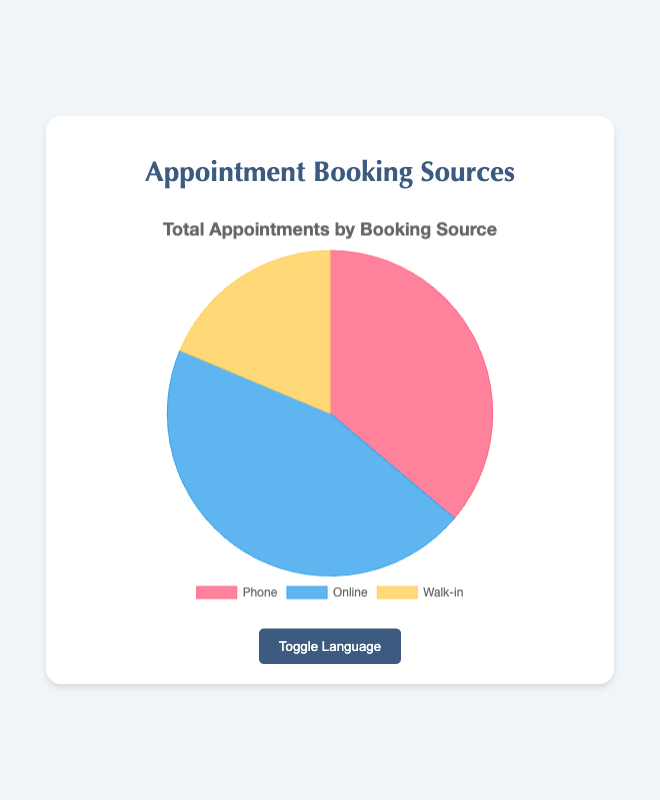What source had the highest number of total appointments? To answer this, sum the appointments from each source across all months. The totals are: Phone: 600, Online: 750, Walk-in: 310. The highest total number comes from the Online source.
Answer: Online How many more appointments were booked online than by phone? To find this, subtract the total phone appointments from total online appointments. Online: 750, Phone: 600. So, 750 - 600 = 150.
Answer: 150 What is the average number of appointments booked by walk-in each month? To determine the average, divide the total walk-in appointments by the number of months. Total walk-in: 310, Months: 5. So, 310 / 5 = 62.
Answer: 62 Which month had the highest number of phone appointments? Review the phone appointment data for each month. January: 120, February: 110, March: 100, April: 130, May: 140. May has the highest number with 140 appointments.
Answer: May If you combined phone and walk-in bookings, would they exceed online bookings? Sum the total phone and walk-in bookings and compare with the total online bookings. Phone + Walk-in: 600 + 310 = 910, Online: 750. Since 910 > 750, combined phone and walk-in exceed online bookings.
Answer: Yes In which month did online appoints surpass phone appointments by the largest margin? Calculate the difference between online and phone appointments for each month and find the one with the largest margin. January: 150 - 120 = 30, February: 160 - 110 = 50, March: 170 - 100 = 70, April: 140 - 130 = 10, May: 130 - 140 = -10. March has the largest margin of 70.
Answer: March What percentage of total appointments were booked by phone? To find this, divide the total phone appointments by the total of all appointments and multiply by 100. Total appointments: 1660, Phone: 600. So, (600 / 1660) * 100 ≈ 36.14%.
Answer: 36.14% What color represents the walk-in bookings in the chart? By observing the pie chart, identify the color segment representing walk-in, which is the smallest segment. It is yellow in color.
Answer: Yellow Among phone and walk-in bookings, which had a greater increase from February to March? Look at the change between February to March for both sources. Phone: 110 to 100 (decrease), Walk-in: 60 to 70 (increase). Hence, walk-in had a greater increase.
Answer: Walk-in 